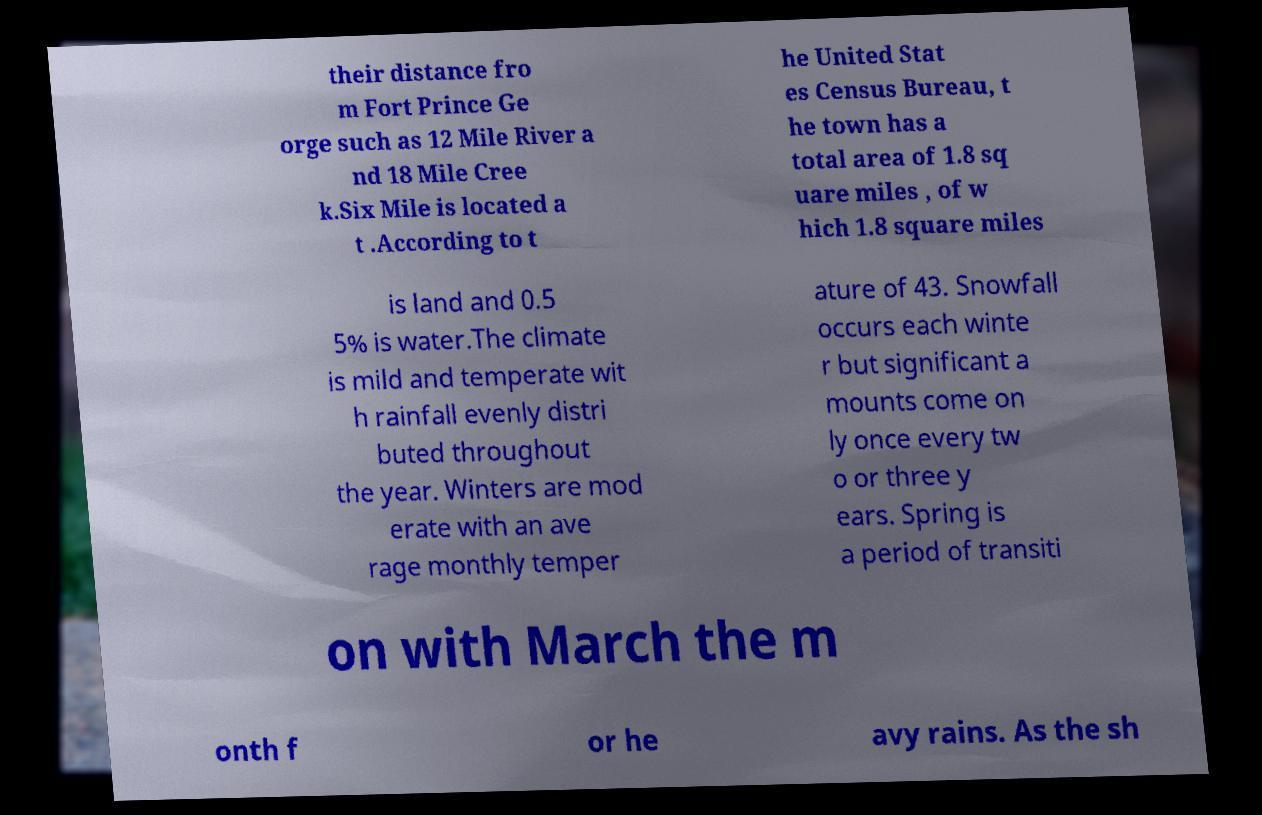Please identify and transcribe the text found in this image. their distance fro m Fort Prince Ge orge such as 12 Mile River a nd 18 Mile Cree k.Six Mile is located a t .According to t he United Stat es Census Bureau, t he town has a total area of 1.8 sq uare miles , of w hich 1.8 square miles is land and 0.5 5% is water.The climate is mild and temperate wit h rainfall evenly distri buted throughout the year. Winters are mod erate with an ave rage monthly temper ature of 43. Snowfall occurs each winte r but significant a mounts come on ly once every tw o or three y ears. Spring is a period of transiti on with March the m onth f or he avy rains. As the sh 